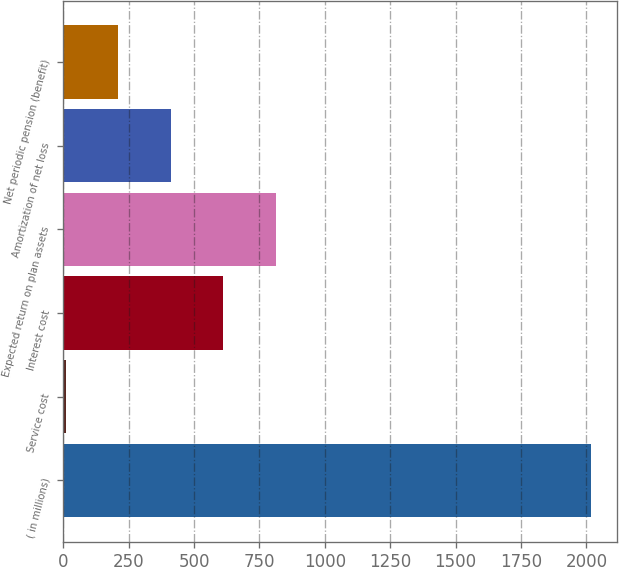<chart> <loc_0><loc_0><loc_500><loc_500><bar_chart><fcel>( in millions)<fcel>Service cost<fcel>Interest cost<fcel>Expected return on plan assets<fcel>Amortization of net loss<fcel>Net periodic pension (benefit)<nl><fcel>2016<fcel>9<fcel>611.1<fcel>811.8<fcel>410.4<fcel>209.7<nl></chart> 